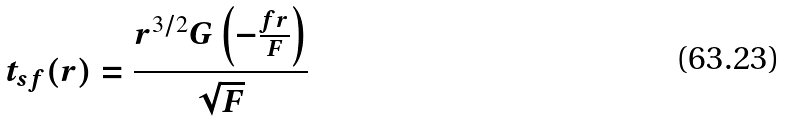<formula> <loc_0><loc_0><loc_500><loc_500>t _ { s f } ( r ) = \frac { r ^ { 3 / 2 } G \left ( - \frac { f r } { F } \right ) } { \sqrt { F } }</formula> 